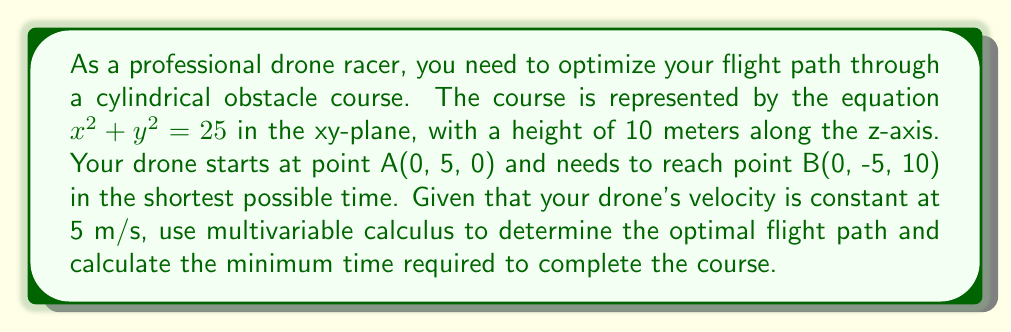Can you answer this question? To solve this problem, we'll use the calculus of variations to find the optimal path that minimizes the time taken.

Step 1: Set up the problem
The time taken to travel along a path is given by the line integral:
$$T = \int_{A}^{B} \frac{ds}{v}$$
where $ds = \sqrt{dx^2 + dy^2 + dz^2}$ and $v = 5$ m/s (constant).

Step 2: Parameterize the path
Let's parameterize the path using cylindrical coordinates:
$$x = r\cos\theta$$
$$y = r\sin\theta$$
$$z = h$$
where $r$ is the distance from the z-axis, $\theta$ is the angle in the xy-plane, and $h$ is the height.

Step 3: Express the time integral
$$T = \frac{1}{5}\int_{0}^{1} \sqrt{(\frac{dr}{dt})^2 + (r\frac{d\theta}{dt})^2 + (\frac{dh}{dt})^2} dt$$

Step 4: Apply the Euler-Lagrange equation
The Euler-Lagrange equation for this problem is:
$$\frac{d}{dt}(\frac{\partial L}{\partial \dot{q}}) - \frac{\partial L}{\partial q} = 0$$
where $L = \sqrt{(\frac{dr}{dt})^2 + (r\frac{d\theta}{dt})^2 + (\frac{dh}{dt})^2}$

Applying this equation to $r$, $\theta$, and $h$, we get:
$$\frac{d^2r}{dt^2} - r(\frac{d\theta}{dt})^2 = 0$$
$$\frac{d}{dt}(r^2\frac{d\theta}{dt}) = 0$$
$$\frac{d^2h}{dt^2} = 0$$

Step 5: Solve the equations
From the third equation, we get:
$$h = at + b$$
where $a$ and $b$ are constants.

From the second equation:
$$r^2\frac{d\theta}{dt} = c$$
where $c$ is a constant.

Step 6: Determine the optimal path
The optimal path is a helix around the cylindrical obstacle. The drone should maintain a constant distance from the z-axis (r = 5) and ascend at a constant rate.

Step 7: Calculate the minimum time
The length of the helical path is:
$$L = \sqrt{(\pi r)^2 + h^2} = \sqrt{(5\pi)^2 + 10^2} \approx 18.07 \text{ m}$$

The minimum time required is:
$$T = \frac{L}{v} = \frac{18.07}{5} \approx 3.61 \text{ s}$$
Answer: $3.61$ seconds 